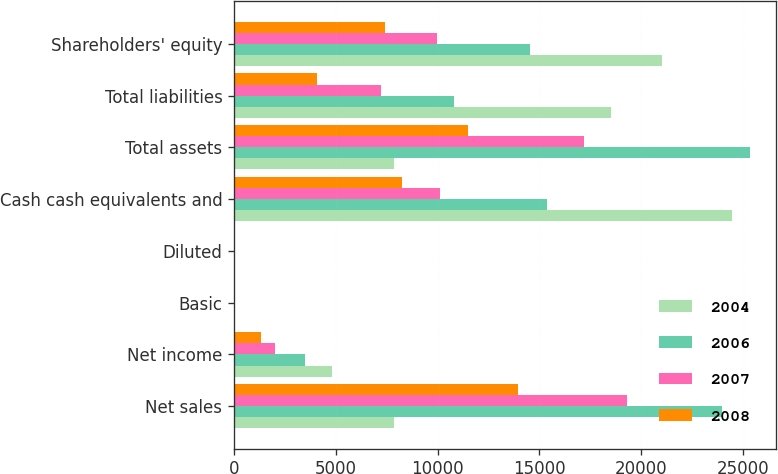Convert chart to OTSL. <chart><loc_0><loc_0><loc_500><loc_500><stacked_bar_chart><ecel><fcel>Net sales<fcel>Net income<fcel>Basic<fcel>Diluted<fcel>Cash cash equivalents and<fcel>Total assets<fcel>Total liabilities<fcel>Shareholders' equity<nl><fcel>2004<fcel>7844.5<fcel>4834<fcel>5.48<fcel>5.36<fcel>24490<fcel>7844.5<fcel>18542<fcel>21030<nl><fcel>2006<fcel>24006<fcel>3496<fcel>4.04<fcel>3.93<fcel>15386<fcel>25347<fcel>10815<fcel>14532<nl><fcel>2007<fcel>19315<fcel>1989<fcel>2.36<fcel>2.27<fcel>10110<fcel>17205<fcel>7221<fcel>9984<nl><fcel>2008<fcel>13931<fcel>1328<fcel>1.64<fcel>1.55<fcel>8261<fcel>11516<fcel>4088<fcel>7428<nl></chart> 